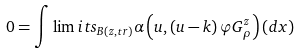<formula> <loc_0><loc_0><loc_500><loc_500>0 = \int \lim i t s _ { B \left ( z , t r \right ) } \alpha \left ( u , \left ( u - k \right ) \varphi G _ { \rho } ^ { z } \right ) \left ( d x \right )</formula> 